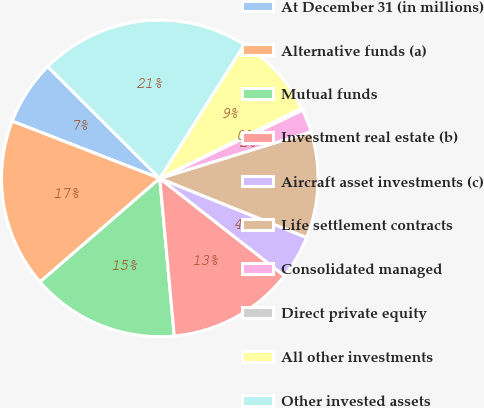Convert chart to OTSL. <chart><loc_0><loc_0><loc_500><loc_500><pie_chart><fcel>At December 31 (in millions)<fcel>Alternative funds (a)<fcel>Mutual funds<fcel>Investment real estate (b)<fcel>Aircraft asset investments (c)<fcel>Life settlement contracts<fcel>Consolidated managed<fcel>Direct private equity<fcel>All other investments<fcel>Other invested assets<nl><fcel>6.59%<fcel>17.24%<fcel>15.11%<fcel>12.98%<fcel>4.47%<fcel>10.85%<fcel>2.34%<fcel>0.21%<fcel>8.72%<fcel>21.49%<nl></chart> 